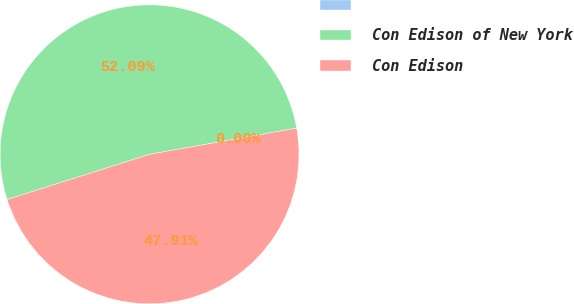Convert chart to OTSL. <chart><loc_0><loc_0><loc_500><loc_500><pie_chart><ecel><fcel>Con Edison of New York<fcel>Con Edison<nl><fcel>0.0%<fcel>52.09%<fcel>47.91%<nl></chart> 